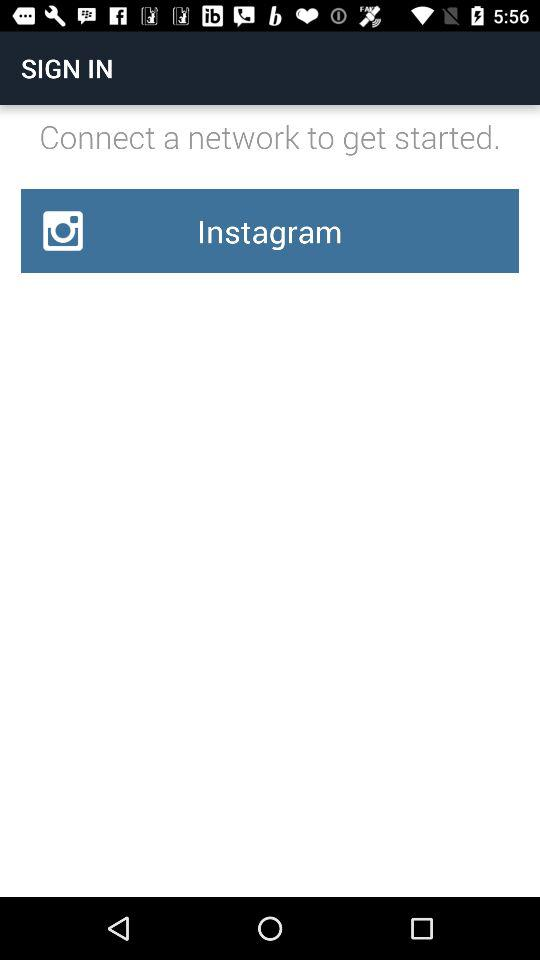What application can be used to sign in? The application that can be used to sign in is "Instagram". 